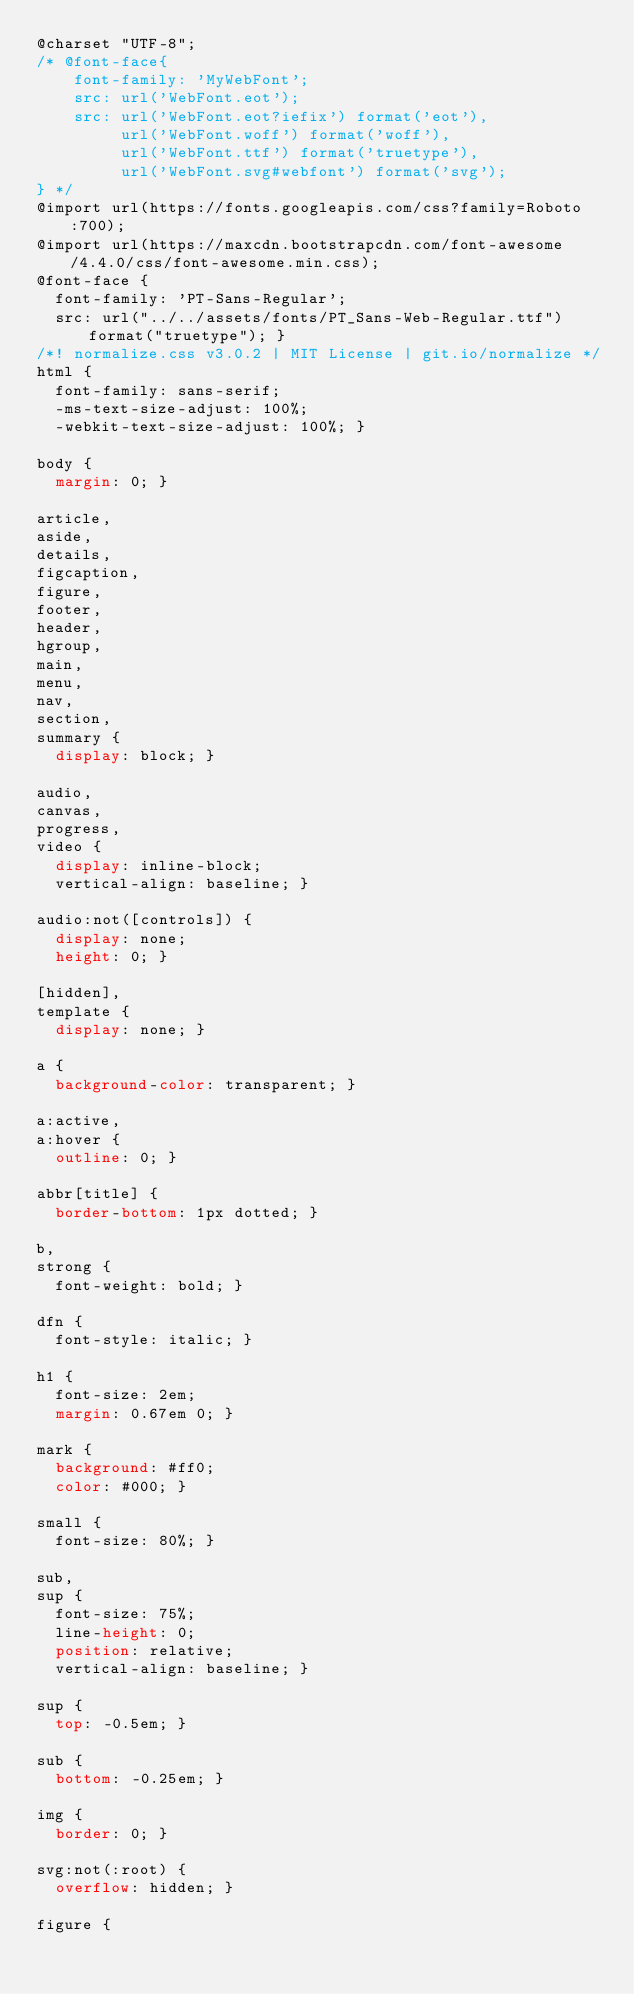<code> <loc_0><loc_0><loc_500><loc_500><_CSS_>@charset "UTF-8";
/* @font-face{ 
    font-family: 'MyWebFont';
    src: url('WebFont.eot');
    src: url('WebFont.eot?iefix') format('eot'),
         url('WebFont.woff') format('woff'),
         url('WebFont.ttf') format('truetype'),
         url('WebFont.svg#webfont') format('svg');
} */
@import url(https://fonts.googleapis.com/css?family=Roboto:700);
@import url(https://maxcdn.bootstrapcdn.com/font-awesome/4.4.0/css/font-awesome.min.css);
@font-face {
  font-family: 'PT-Sans-Regular';
  src: url("../../assets/fonts/PT_Sans-Web-Regular.ttf") format("truetype"); }
/*! normalize.css v3.0.2 | MIT License | git.io/normalize */
html {
  font-family: sans-serif;
  -ms-text-size-adjust: 100%;
  -webkit-text-size-adjust: 100%; }

body {
  margin: 0; }

article,
aside,
details,
figcaption,
figure,
footer,
header,
hgroup,
main,
menu,
nav,
section,
summary {
  display: block; }

audio,
canvas,
progress,
video {
  display: inline-block;
  vertical-align: baseline; }

audio:not([controls]) {
  display: none;
  height: 0; }

[hidden],
template {
  display: none; }

a {
  background-color: transparent; }

a:active,
a:hover {
  outline: 0; }

abbr[title] {
  border-bottom: 1px dotted; }

b,
strong {
  font-weight: bold; }

dfn {
  font-style: italic; }

h1 {
  font-size: 2em;
  margin: 0.67em 0; }

mark {
  background: #ff0;
  color: #000; }

small {
  font-size: 80%; }

sub,
sup {
  font-size: 75%;
  line-height: 0;
  position: relative;
  vertical-align: baseline; }

sup {
  top: -0.5em; }

sub {
  bottom: -0.25em; }

img {
  border: 0; }

svg:not(:root) {
  overflow: hidden; }

figure {</code> 